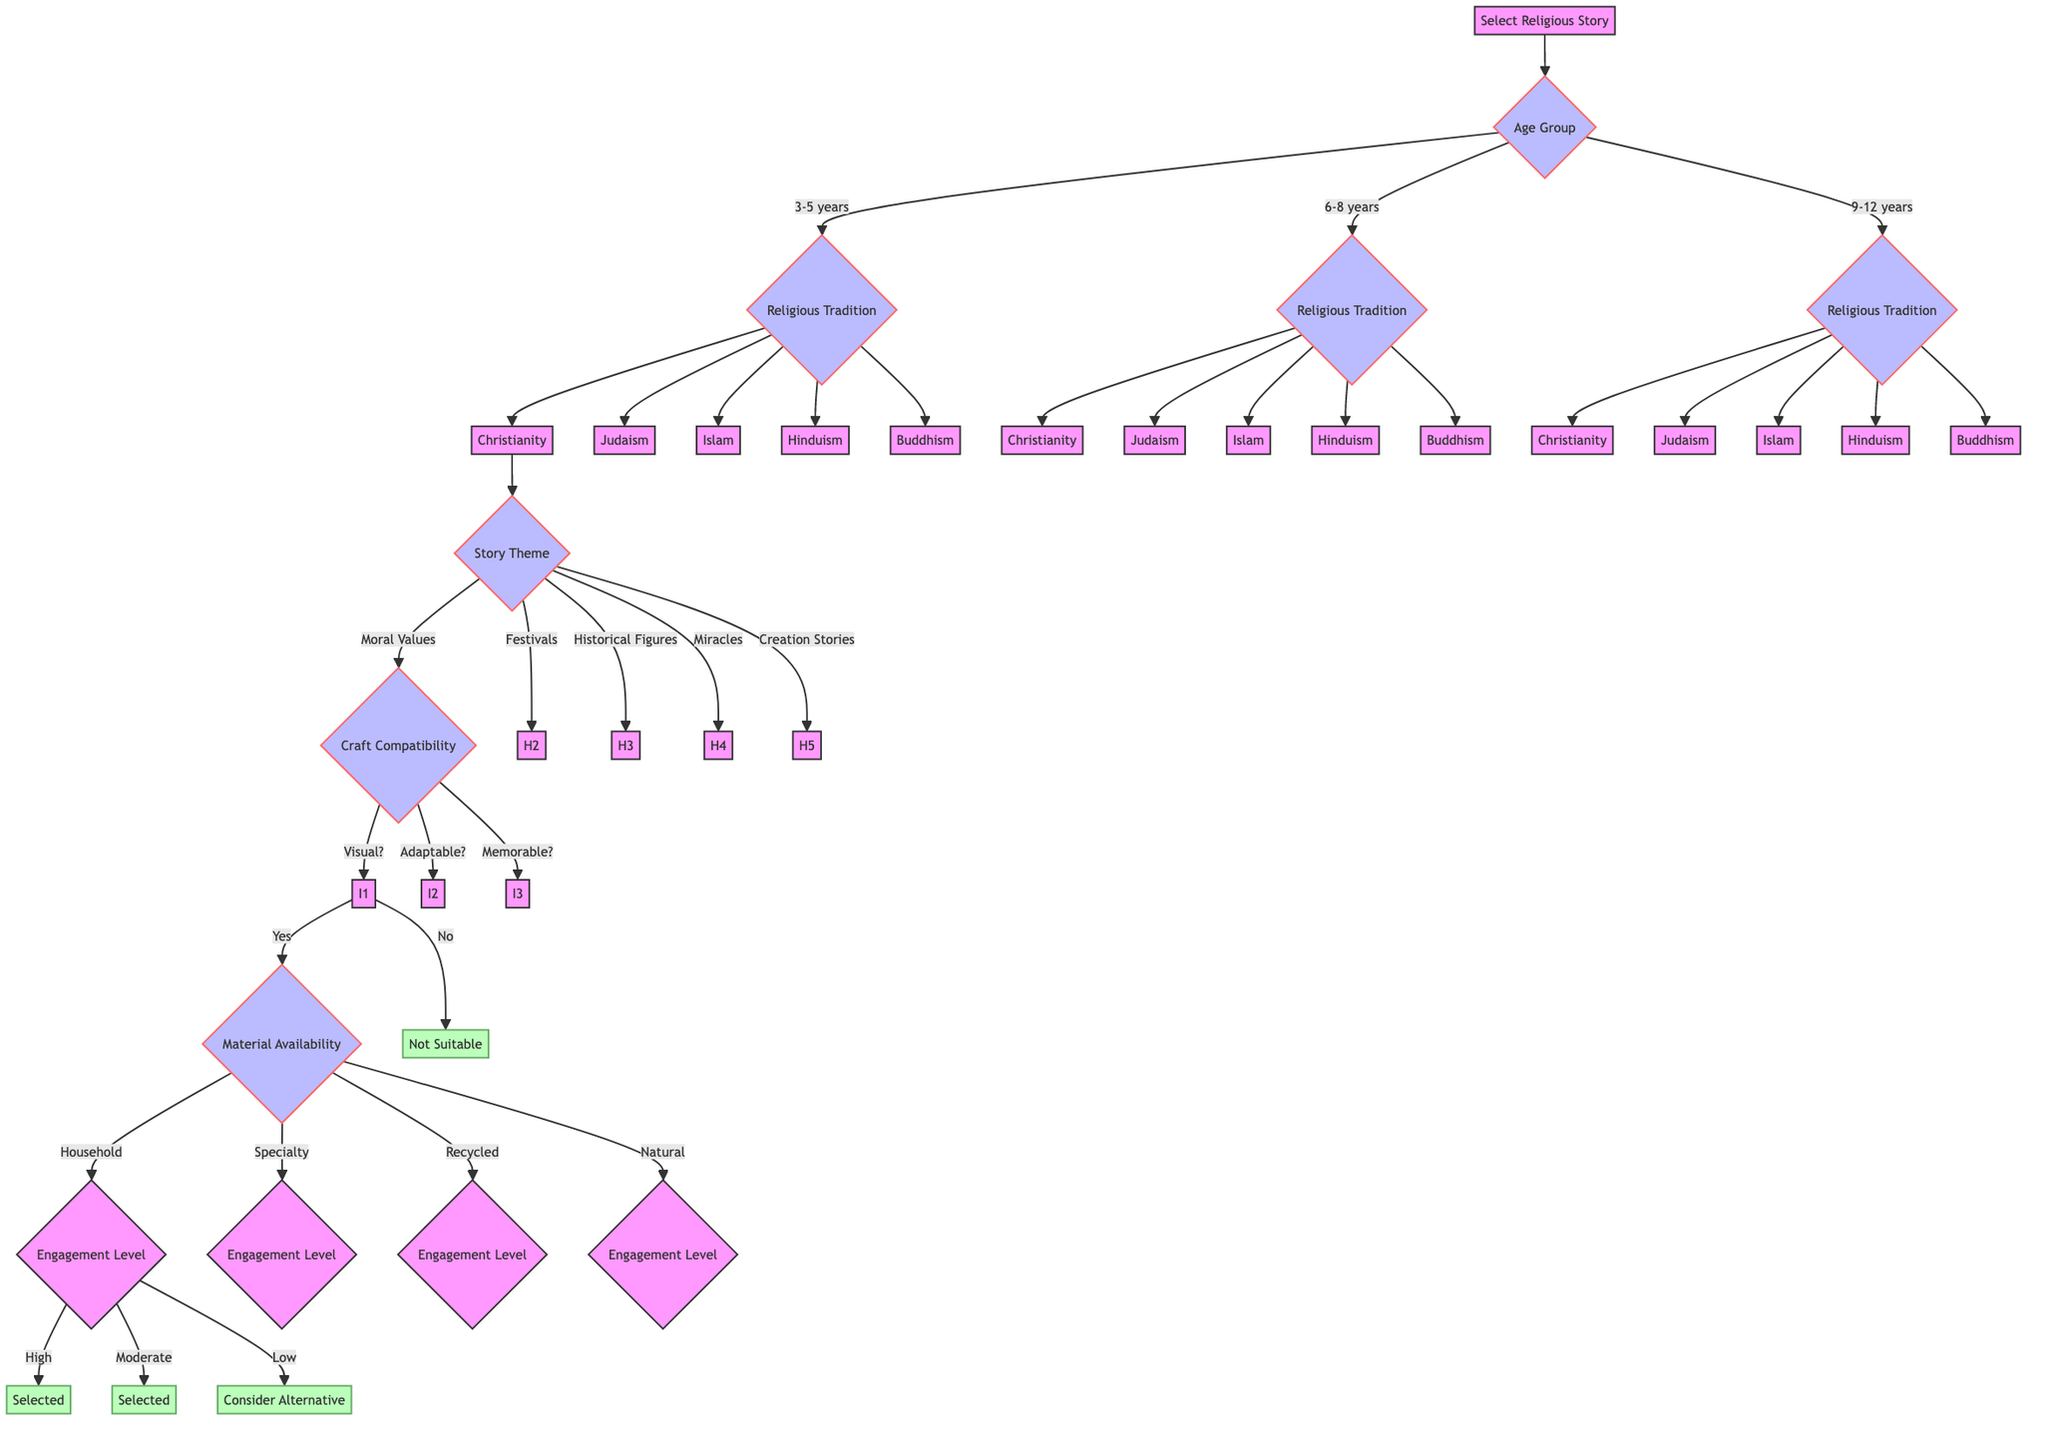What are the age groups specified in the diagram? The diagram lists three age groups to choose from when selecting a religious story, which are: 3-5 years, 6-8 years, and 9-12 years.
Answer: 3-5 years, 6-8 years, 9-12 years How many religious traditions can be selected? Each age group subsequently leads to a choice of religious tradition. The diagram shows five options for religious traditions: Christianity, Judaism, Islam, Hinduism, and Buddhism.
Answer: 5 Which theme is associated with the story after selecting Christianity for 3-5 years? After selecting Christianity for 3-5 years, the next step involves choosing a story theme, which can be any of the five options: Moral Values, Festivals, Historical Figures, Miracles, or Creation Stories.
Answer: Moral Values, Festivals, Historical Figures, Miracles, Creation Stories What decision follows after determining if the story is visual? If the story is determined to be visual (answered 'Yes'), the next step concerns the Material Availability, indicating different types of materials required for the craft.
Answer: Material Availability What happens if the story does not involve memorable characters? If the story does not involve memorable characters (answered 'No'), the process leads to the "Not Suitable" conclusion, indicating that no craft activity is appropriate for that story.
Answer: Not Suitable If recycled materials are chosen, what can be the engagement levels? After selecting recycled materials as the type of material, the diagram indicates three possible engagement levels: Highly Interactive, Moderately Interactive, and Low Interaction.
Answer: Highly Interactive, Moderately Interactive, Low Interaction What outcome is predicted for a highly interactive craft that uses common household materials? In the case of a highly interactive craft that utilizes common household materials, the output of the decision path will indicate a 'Selected' outcome, suggesting that this combination is suitable for a craft activity.
Answer: Selected Can a craft activity be based on a story that is not adaptable to simple art forms? Following the diagram’s logic, if the story is not adaptable to simple art forms (answered 'No'), the activity would also lead to 'Not Suitable', confirming that it cannot be selected for a craft activity.
Answer: Not Suitable What is the final decision after evaluating all nodes for the 9-12 years age group? The final decision for the 9-12 years age group will depend on the responses to all preceding nodes, leading to various possible outcomes based on combinations of religious tradition, story theme, craft compatibility, and material availability. It could be one of selected or not suitable outcomes.
Answer: Varies based on inputs 